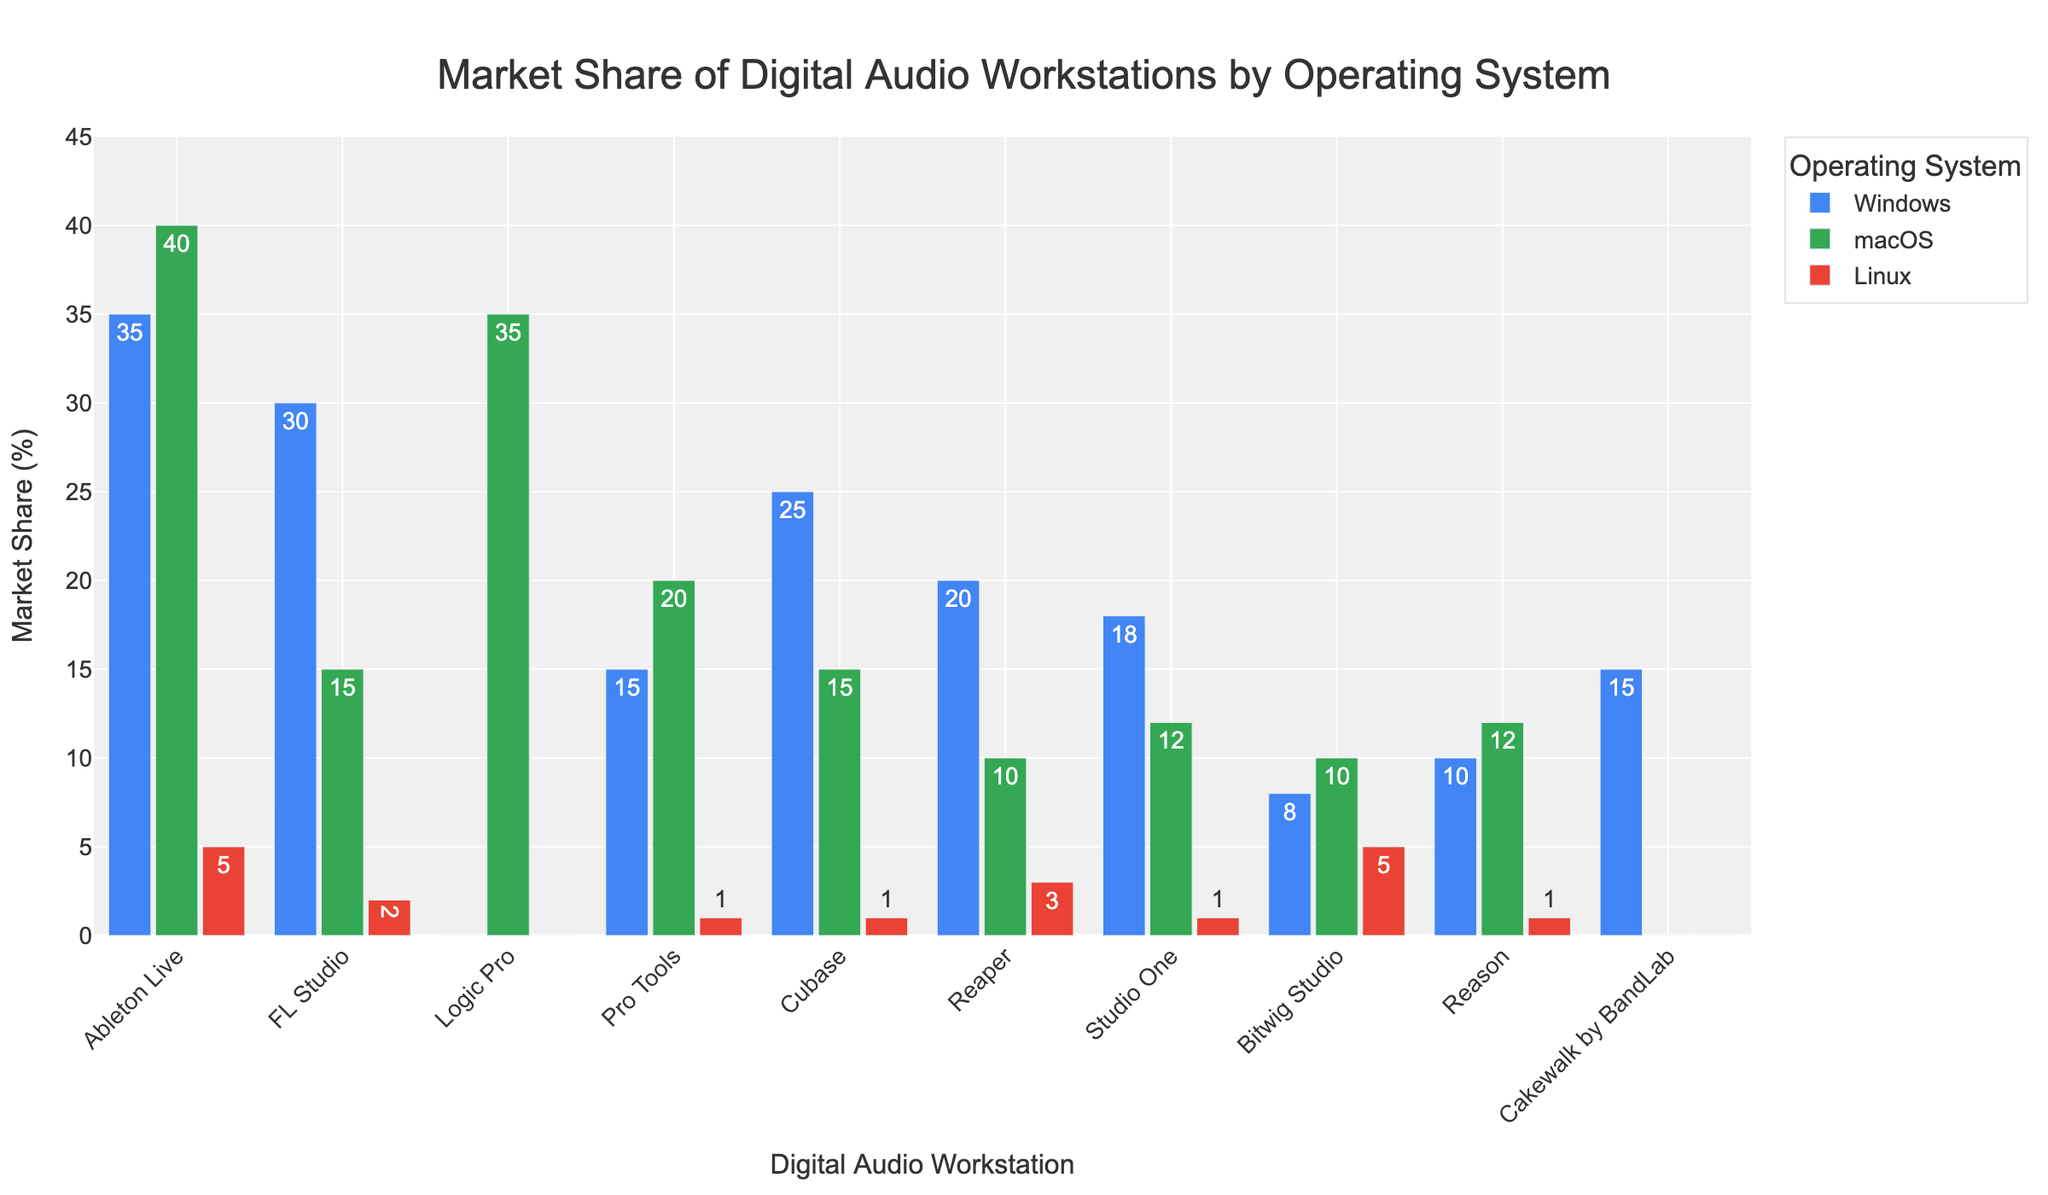Which DAW has the highest market share across all operating systems? Looking at the chart, Ableton Live has the highest bars for both Windows and macOS. Summing its market shares across all operating systems (35 for Windows, 40 for macOS, 5 for Linux) results in a total of 80, which is higher than for any other DAW.
Answer: Ableton Live Which DAW is least used on Windows? By observing the height of the bars for DAWs on Windows, Logic Pro has zero height, indicating it is not used on Windows at all.
Answer: Logic Pro What’s the total market share of Pro Tools across all operating systems? Summing the market share for Pro Tools across Windows (15), macOS (20), and Linux (1) gives a total of 36.
Answer: 36 Which DAW has the second highest market share on macOS? Checking the bar heights for macOS, Ableton Live has the highest share with 40, and Logic Pro is second with 35.
Answer: Logic Pro How does the market share of Reaper on macOS compare to its market share on Linux? The bar for Reaper on macOS is at 10, while on Linux it is at 3, indicating that its market share is higher on macOS.
Answer: Higher on macOS Which DAW has the most balanced market share across all three operating systems? Bitwig Studio has relatively balanced bars with 8 (Windows), 10 (macOS), and 5 (Linux), suggesting it is the most balanced.
Answer: Bitwig Studio Is there any DAW that has a zero market share on one or more operating systems? Logic Pro has zero market share on Windows and Linux, and Cakewalk by BandLab has zero market share on macOS and Linux.
Answer: Yes What is the combined market share of DAWs on Linux that have at least 5% market share? Ableton Live has 5%, and Bitwig Studio has 5%, summing them results in 10%.
Answer: 10% Which DAW has the smallest total market share across all operating systems? Summing up the market shares for each DAW, Cakewalk by BandLab has the smallest combined total (15 on Windows + 0 on macOS + 0 on Linux = 15).
Answer: Cakewalk by BandLab 